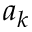Convert formula to latex. <formula><loc_0><loc_0><loc_500><loc_500>a _ { k }</formula> 